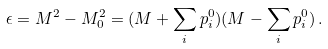Convert formula to latex. <formula><loc_0><loc_0><loc_500><loc_500>\epsilon = M ^ { 2 } - M _ { 0 } ^ { 2 } = ( M + \sum _ { i } p _ { i } ^ { 0 } ) ( M - \sum _ { i } p _ { i } ^ { 0 } ) \, .</formula> 